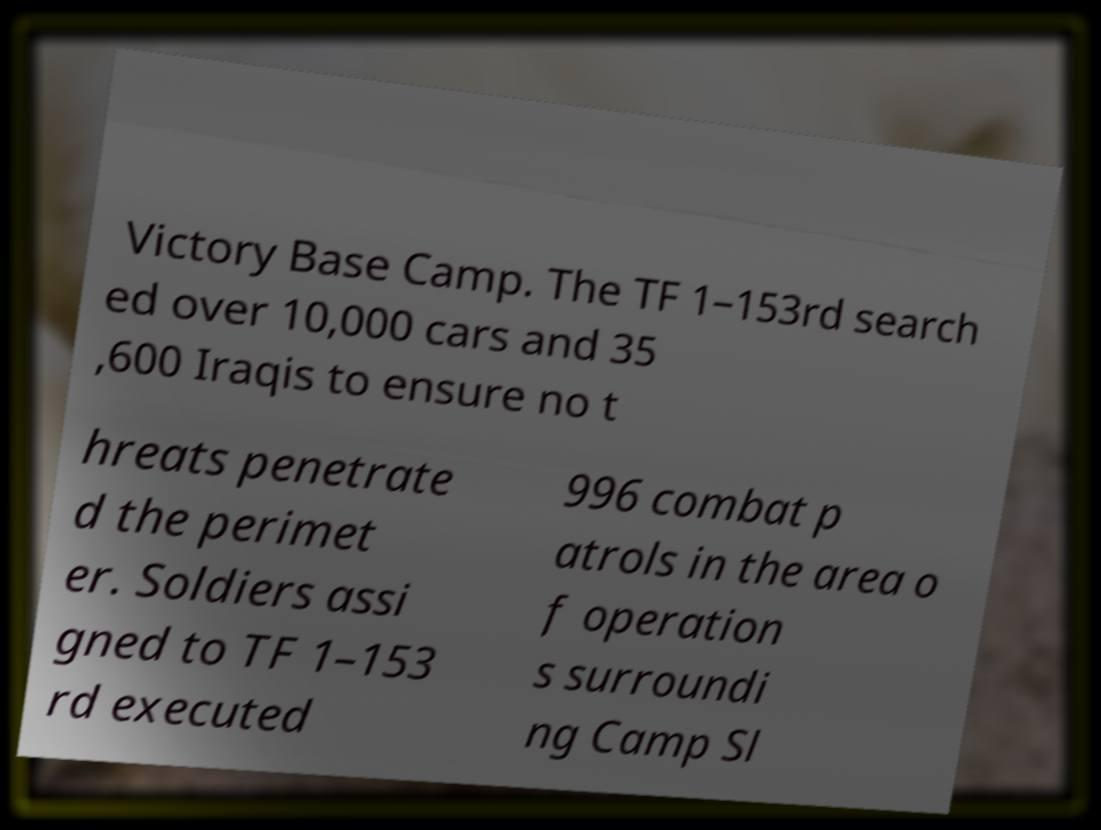There's text embedded in this image that I need extracted. Can you transcribe it verbatim? Victory Base Camp. The TF 1–153rd search ed over 10,000 cars and 35 ,600 Iraqis to ensure no t hreats penetrate d the perimet er. Soldiers assi gned to TF 1–153 rd executed 996 combat p atrols in the area o f operation s surroundi ng Camp Sl 